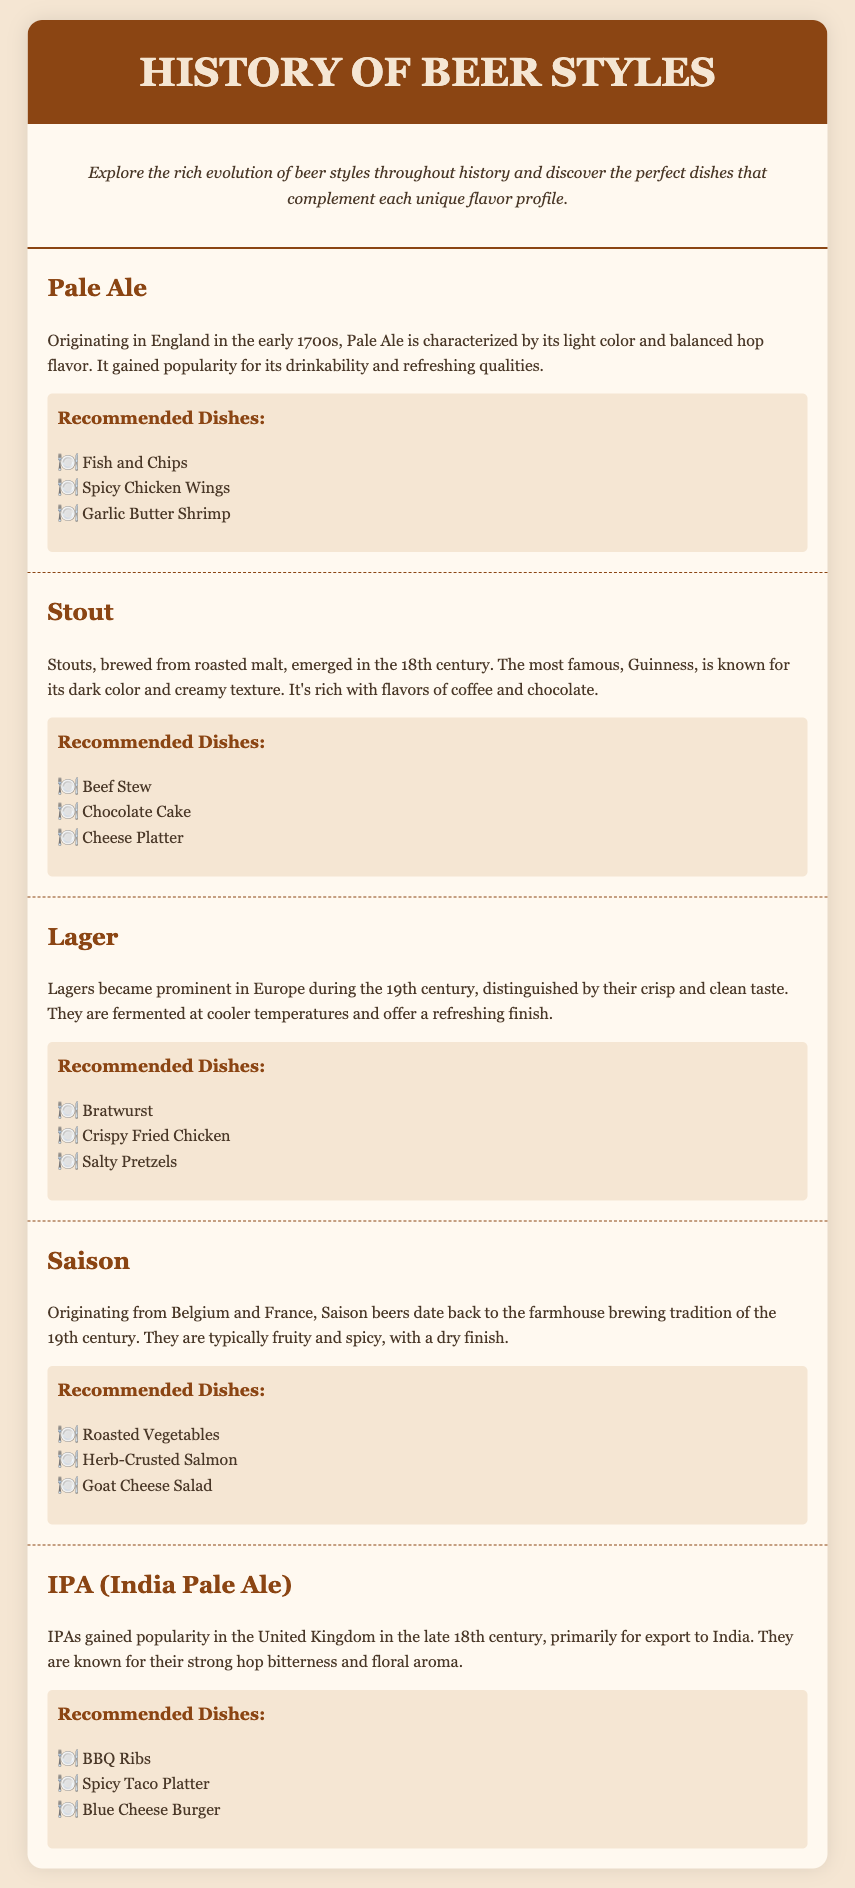What is the origin of Pale Ale? The document states that Pale Ale originated in England in the early 1700s.
Answer: England in the early 1700s What are the recommended dishes for Stout? The recommended dishes for Stout listed in the document are Beef Stew, Chocolate Cake, and Cheese Platter.
Answer: Beef Stew, Chocolate Cake, Cheese Platter When did Lagers become prominent in Europe? The document indicates that Lagers became prominent in Europe during the 19th century.
Answer: 19th century What is a key flavor characteristic of IPA? According to the document, IPAs are known for their strong hop bitterness and floral aroma.
Answer: Strong hop bitterness Which beer style is typically fruity and spicy? The document describes Saison beers as typically fruity and spicy.
Answer: Saison What type of finish do Saison beers have? The document mentions that Saison beers have a dry finish.
Answer: Dry finish What type of dishes pair well with Lager? The recommended dishes that pair well with Lager include Bratwurst, Crispy Fried Chicken, and Salty Pretzels according to the document.
Answer: Bratwurst, Crispy Fried Chicken, Salty Pretzels How is the Stout beer described in terms of texture? The document describes Stouts as having a creamy texture.
Answer: Creamy texture What historical farming tradition does Saison originate from? The document states that Saison beers originated from the farmhouse brewing tradition.
Answer: Farmhouse brewing tradition 